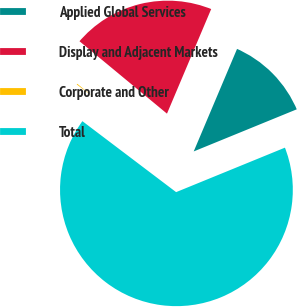Convert chart. <chart><loc_0><loc_0><loc_500><loc_500><pie_chart><fcel>Applied Global Services<fcel>Display and Adjacent Markets<fcel>Corporate and Other<fcel>Total<nl><fcel>12.46%<fcel>20.36%<fcel>0.69%<fcel>66.49%<nl></chart> 